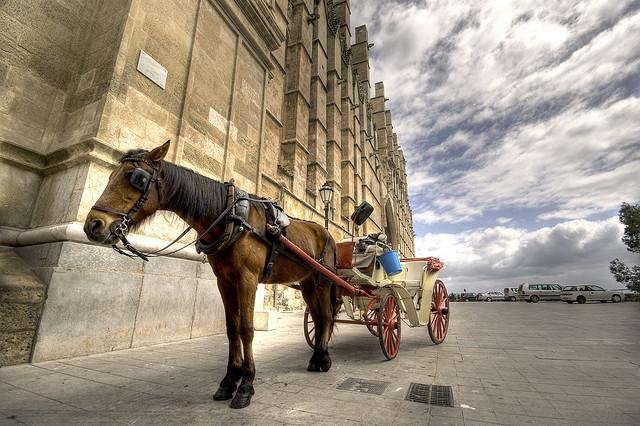This animal is most closely related to what other animal?

Choices:
A) mollusk
B) donkey
C) badger
D) possum donkey 